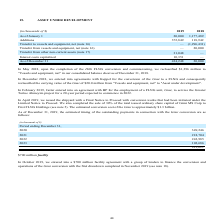According to Golar Lng's financial document, What was the reason for entering into agreements with Keppel in 2018? For the conversion of the Gimi to a FLNG. The document states: "mber 2018, we entered into agreements with Keppel for the conversion of the Gimi to a FLNG and consequently reclassified the carrying value of the Gim..." Also, Which years did Golar enter into agreements with companies like Keppel and BP respectively? The document shows two values: 2018 and 2019. From the document: "(in thousands of $) 2019 2018 As of January 1 20,000 1,177,489 Additions 372,849 118,942 (in thousands of $) 2019 2018 As of January 1 20,000 1,177,48..." Also, What was the conversion cost of the Gimi? According to the financial document, $1.3 billion. The relevant text states: "mated conversion cost of the Gimi is approximately $1.3 billion...." Additionally, Which year was the asset under development as of January 1 higher? According to the financial document, 2018. The relevant text states: "(in thousands of $) 2019 2018 As of January 1 20,000 1,177,489 Additions 372,849 118,942..." Also, can you calculate: What was the change in additions between 2018 and 2019? Based on the calculation: 372,849 - 118,942 , the result is 253907 (in thousands). This is based on the information: "s of January 1 20,000 1,177,489 Additions 372,849 118,942 9 2018 As of January 1 20,000 1,177,489 Additions 372,849 118,942..." The key data points involved are: 118,942, 372,849. Also, can you calculate: What was the percentage change in asset under development as of December 31 between 2018 and 2019? To answer this question, I need to perform calculations using the financial data. The calculation is: (434,248 - 20,000)/20,000 , which equals 2071.24 (percentage). This is based on the information: "rest costs capitalized 10,351 — As of December 31 434,248 20,000 ts capitalized 10,351 — As of December 31 434,248 20,000..." The key data points involved are: 20,000, 434,248. 